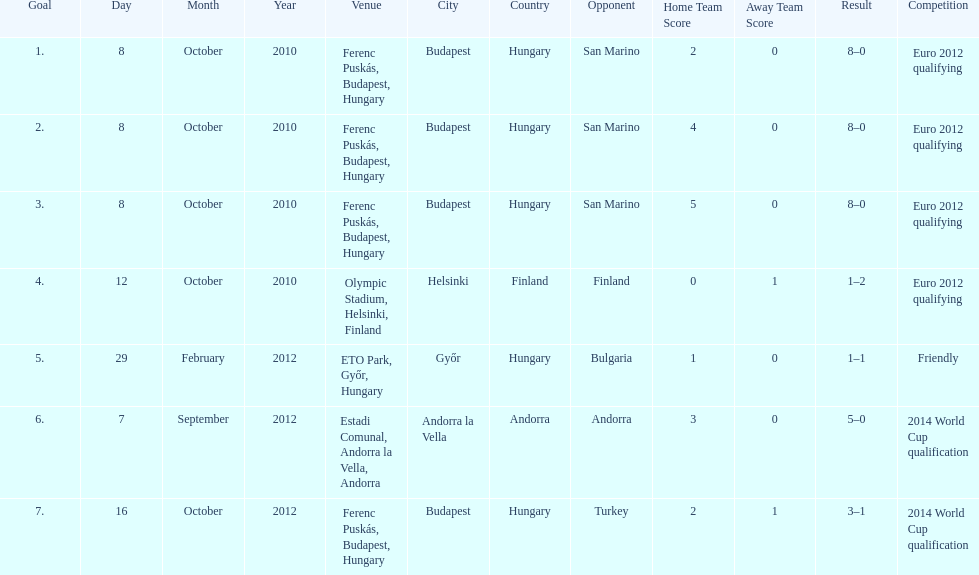How many games did he score but his team lost? 1. 